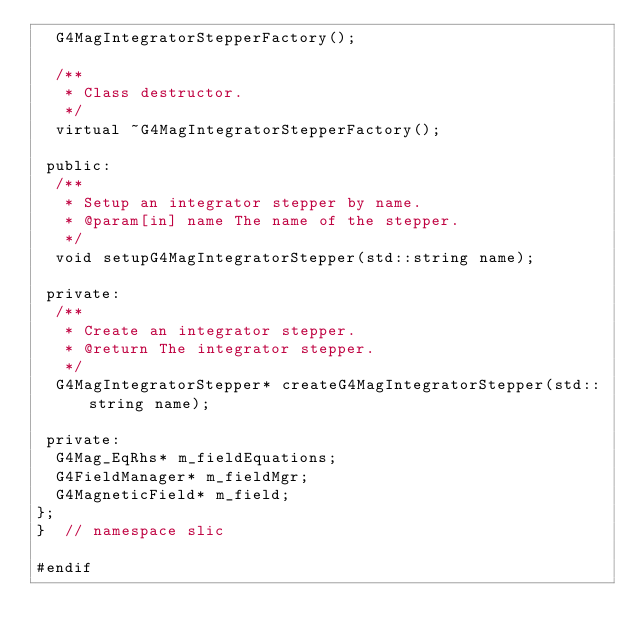Convert code to text. <code><loc_0><loc_0><loc_500><loc_500><_C++_>  G4MagIntegratorStepperFactory();

  /**
   * Class destructor.
   */
  virtual ~G4MagIntegratorStepperFactory();

 public:
  /**
   * Setup an integrator stepper by name.
   * @param[in] name The name of the stepper.
   */
  void setupG4MagIntegratorStepper(std::string name);

 private:
  /**
   * Create an integrator stepper.
   * @return The integrator stepper.
   */
  G4MagIntegratorStepper* createG4MagIntegratorStepper(std::string name);

 private:
  G4Mag_EqRhs* m_fieldEquations;
  G4FieldManager* m_fieldMgr;
  G4MagneticField* m_field;
};
}  // namespace slic

#endif
</code> 